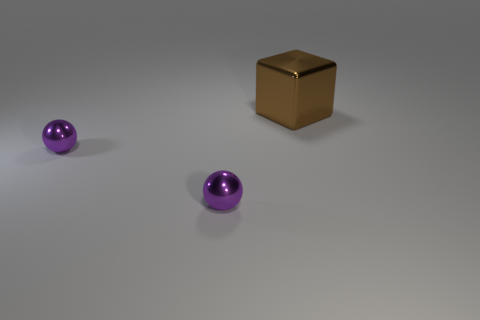Are there any other things that are the same size as the brown block?
Your response must be concise. No. What number of things are shiny things in front of the large brown metallic cube or shiny things that are in front of the brown cube?
Offer a terse response. 2. How many things are objects in front of the metal block or large cubes?
Your answer should be very brief. 3. Is there any other thing that is the same color as the cube?
Offer a very short reply. No. What number of other objects are the same material as the brown object?
Offer a terse response. 2. Is the number of shiny things greater than the number of small purple balls?
Keep it short and to the point. Yes. What color is the large shiny block?
Make the answer very short. Brown. Are there fewer metallic cubes than cyan rubber spheres?
Offer a very short reply. No. Are there any green spheres of the same size as the cube?
Make the answer very short. No. Are there fewer brown metal objects that are behind the brown object than big gray objects?
Make the answer very short. No. 